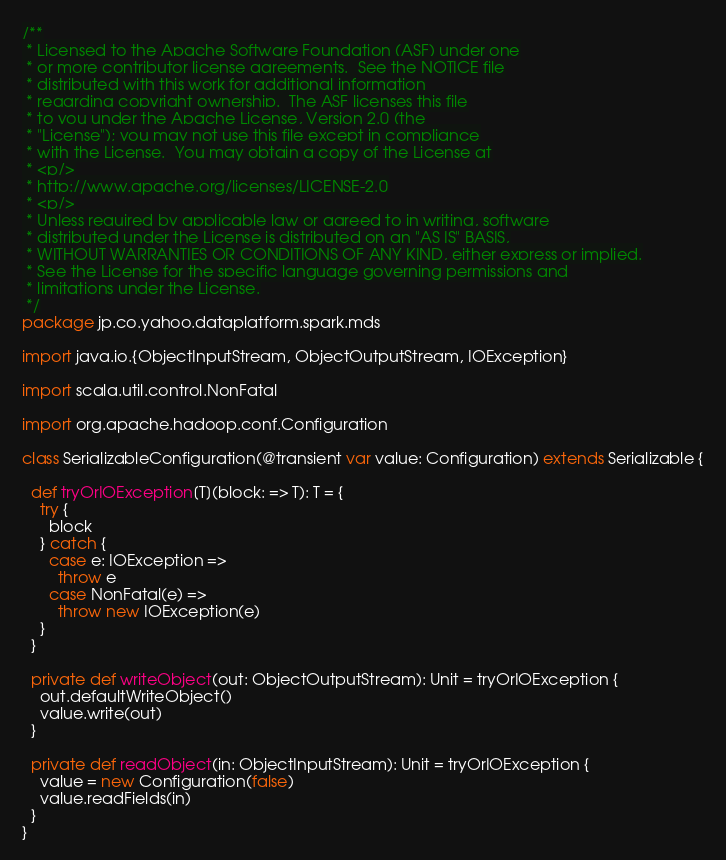Convert code to text. <code><loc_0><loc_0><loc_500><loc_500><_Scala_>/**
 * Licensed to the Apache Software Foundation (ASF) under one
 * or more contributor license agreements.  See the NOTICE file
 * distributed with this work for additional information
 * regarding copyright ownership.  The ASF licenses this file
 * to you under the Apache License, Version 2.0 (the
 * "License"); you may not use this file except in compliance
 * with the License.  You may obtain a copy of the License at
 * <p/>
 * http://www.apache.org/licenses/LICENSE-2.0
 * <p/>
 * Unless required by applicable law or agreed to in writing, software
 * distributed under the License is distributed on an "AS IS" BASIS,
 * WITHOUT WARRANTIES OR CONDITIONS OF ANY KIND, either express or implied.
 * See the License for the specific language governing permissions and
 * limitations under the License.
 */
package jp.co.yahoo.dataplatform.spark.mds

import java.io.{ObjectInputStream, ObjectOutputStream, IOException}

import scala.util.control.NonFatal

import org.apache.hadoop.conf.Configuration

class SerializableConfiguration(@transient var value: Configuration) extends Serializable {

  def tryOrIOException[T](block: => T): T = {
    try {
      block
    } catch {
      case e: IOException =>
        throw e
      case NonFatal(e) =>
        throw new IOException(e)
    }
  }

  private def writeObject(out: ObjectOutputStream): Unit = tryOrIOException {
    out.defaultWriteObject()
    value.write(out)
  }

  private def readObject(in: ObjectInputStream): Unit = tryOrIOException {
    value = new Configuration(false)
    value.readFields(in)
  }
}
</code> 